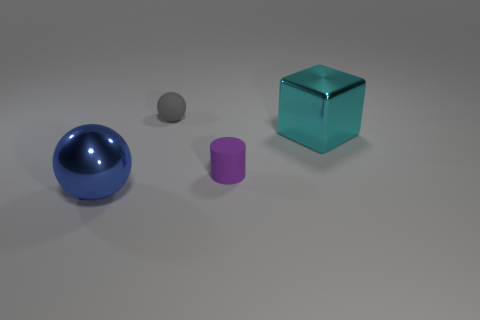How many gray rubber objects have the same shape as the cyan shiny thing?
Keep it short and to the point. 0. What number of big yellow objects are there?
Provide a short and direct response. 0. How big is the object that is both on the left side of the matte cylinder and in front of the cyan metal object?
Your answer should be very brief. Large. There is a cyan shiny thing that is the same size as the blue metal thing; what shape is it?
Ensure brevity in your answer.  Cube. Are there any cyan metal blocks right of the cyan metallic thing that is right of the big blue object?
Your response must be concise. No. The other shiny object that is the same shape as the gray thing is what color?
Give a very brief answer. Blue. Do the ball behind the small purple matte cylinder and the matte cylinder have the same color?
Provide a succinct answer. No. What number of objects are either matte objects in front of the big cyan metallic thing or red rubber spheres?
Offer a very short reply. 1. What is the material of the large thing that is to the right of the big blue object that is to the left of the large thing that is behind the big blue shiny ball?
Offer a terse response. Metal. Is the number of small rubber cylinders in front of the blue shiny sphere greater than the number of gray matte objects to the left of the small purple object?
Your response must be concise. No. 